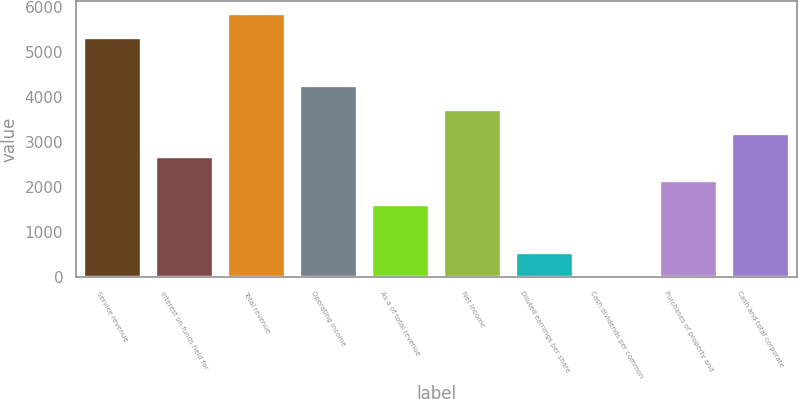Convert chart to OTSL. <chart><loc_0><loc_0><loc_500><loc_500><bar_chart><fcel>Service revenue<fcel>Interest on funds held for<fcel>Total revenue<fcel>Operating income<fcel>As a of total revenue<fcel>Net income<fcel>Diluted earnings per share<fcel>Cash dividends per common<fcel>Purchases of property and<fcel>Cash and total corporate<nl><fcel>5309.8<fcel>2655.5<fcel>5840.66<fcel>4248.08<fcel>1593.78<fcel>3717.22<fcel>532.06<fcel>1.2<fcel>2124.64<fcel>3186.36<nl></chart> 